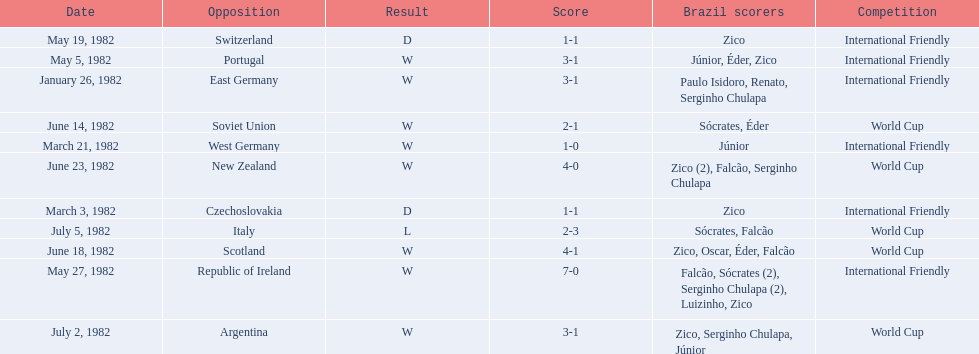Who did brazil play against Soviet Union. Who scored the most goals? Portugal. 